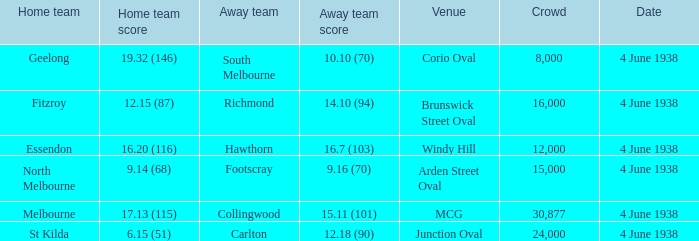How many attended the game at Arden Street Oval? 15000.0. 